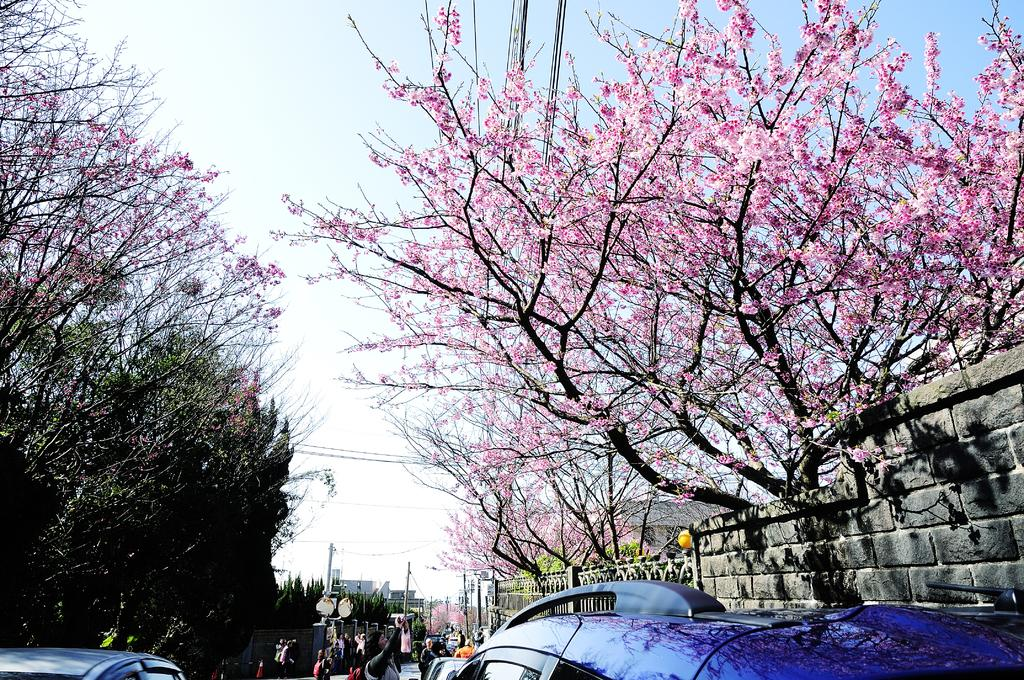What type of structures can be seen in the image? There are buildings in the image. What natural elements are present in the image? There are trees in the image. What man-made objects can be seen in the image? There are poles in the image. Who or what is present in the image? There are people and cars in the image. What is the weather like in the image? The sky is cloudy in the image. Can you see any insects flying around the rose in the image? There is no rose or insect present in the image. What is the desire of the people in the image? The image does not provide information about the desires of the people present. 